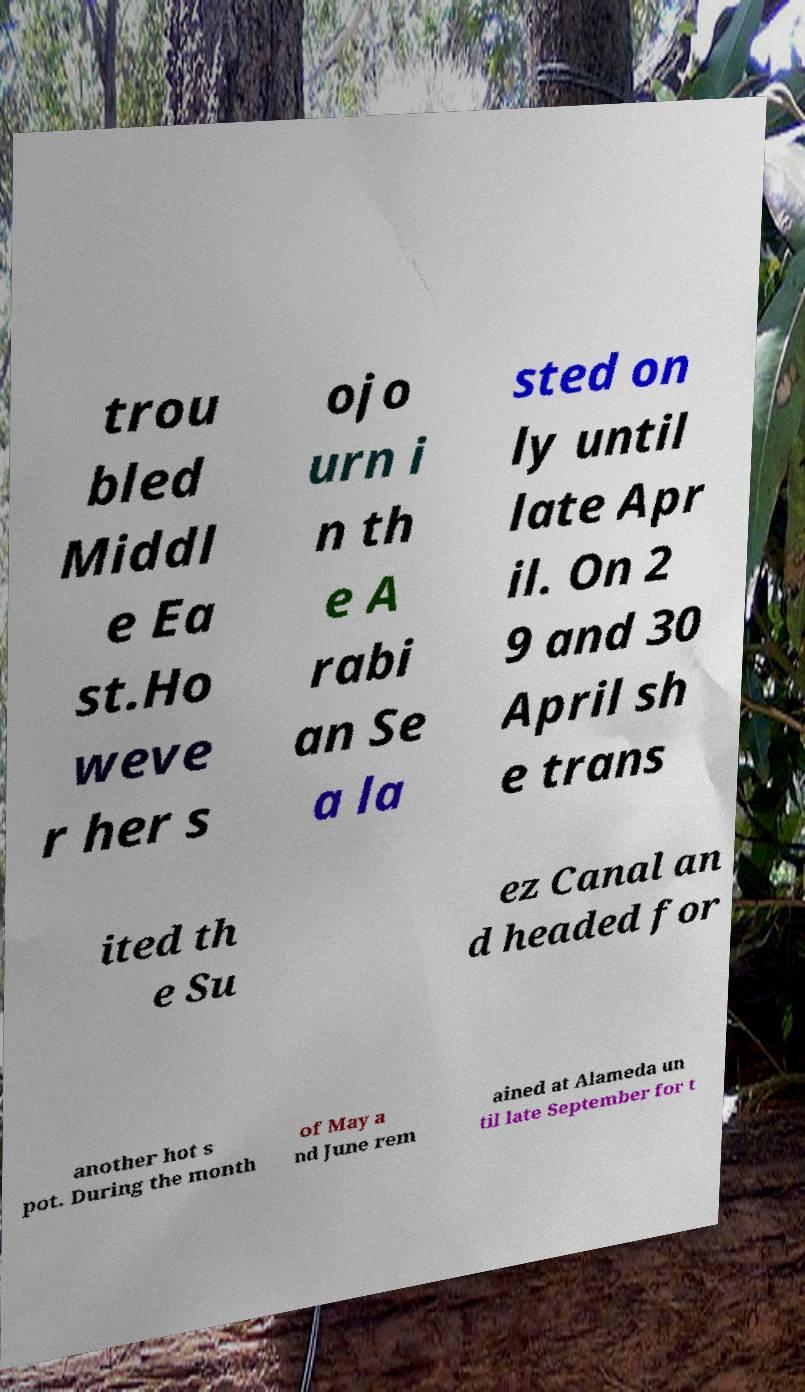Please read and relay the text visible in this image. What does it say? trou bled Middl e Ea st.Ho weve r her s ojo urn i n th e A rabi an Se a la sted on ly until late Apr il. On 2 9 and 30 April sh e trans ited th e Su ez Canal an d headed for another hot s pot. During the month of May a nd June rem ained at Alameda un til late September for t 